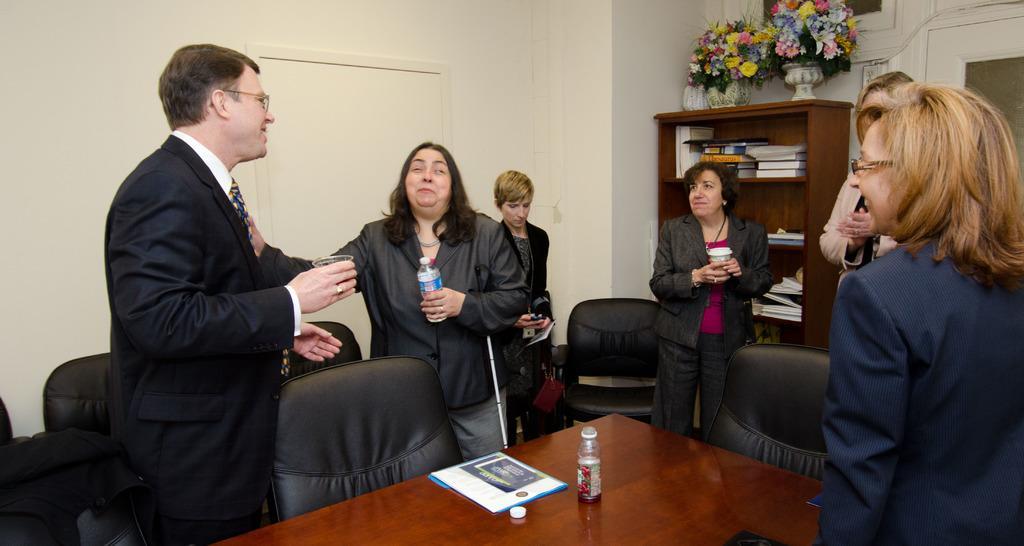Could you give a brief overview of what you see in this image? In this image I can see few people are standing and also I can see smile on few faces. Here I can see chairs and a table. I can also see she is holding a bottle and on this table I can see one more bottle. In the background I can see number of books and few plants. 